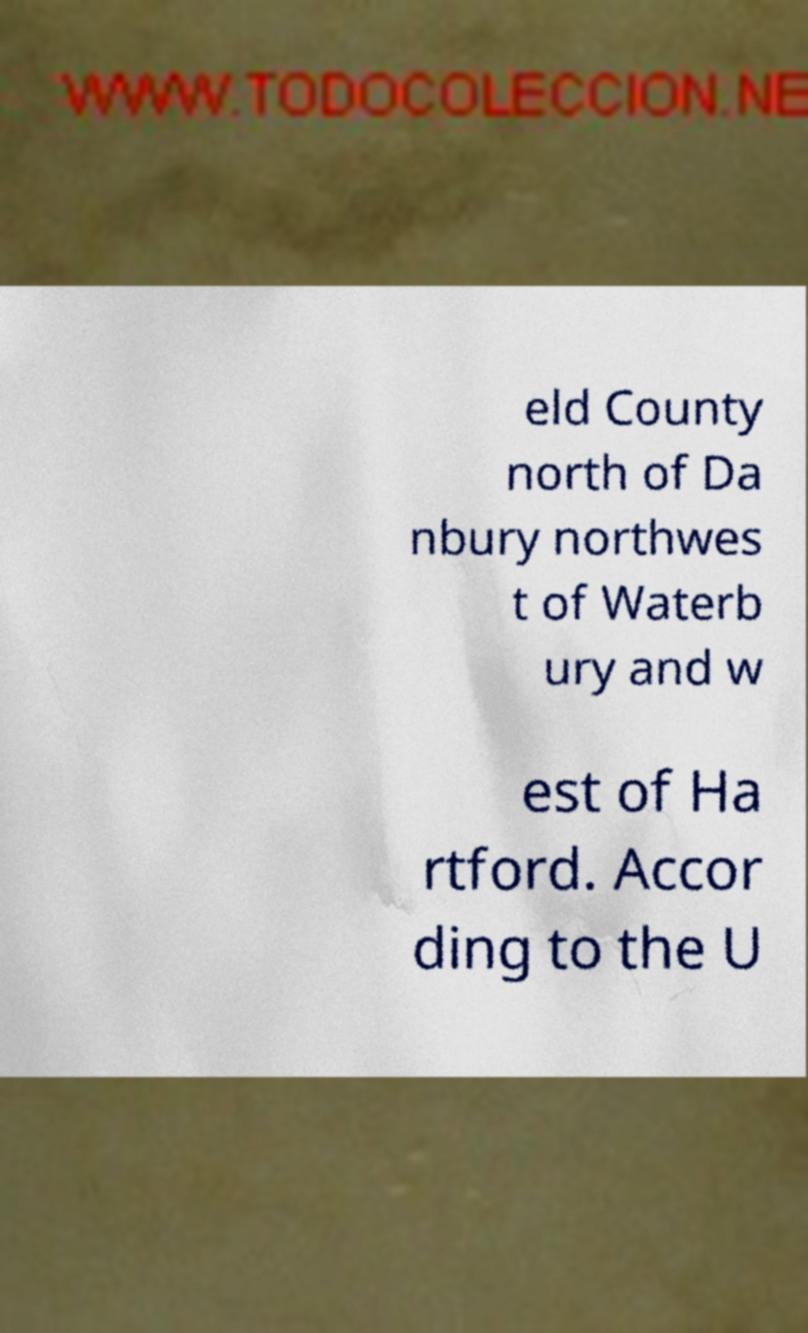Can you accurately transcribe the text from the provided image for me? eld County north of Da nbury northwes t of Waterb ury and w est of Ha rtford. Accor ding to the U 